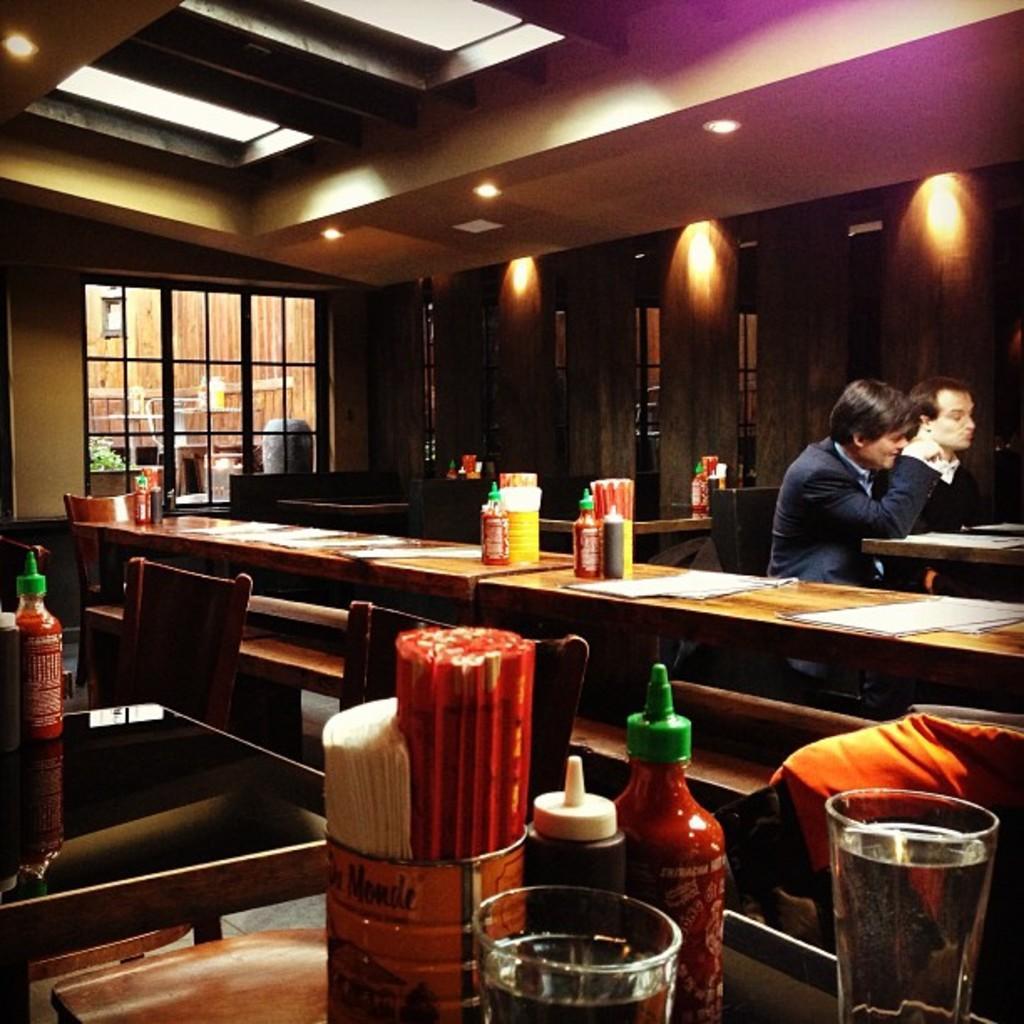How would you summarize this image in a sentence or two? In this image there are 2 persons sitting in the chair , near the table and in table there are bottle, glass , paper, straws ,chair and in back ground there are lights , ceiling, plant , building. 